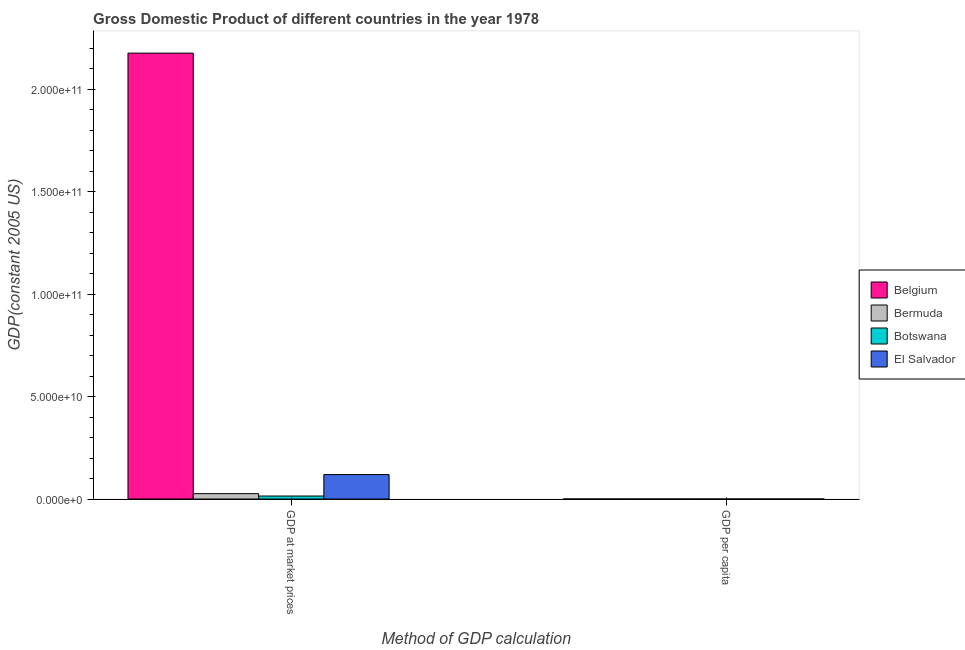Are the number of bars per tick equal to the number of legend labels?
Your answer should be compact. Yes. How many bars are there on the 2nd tick from the right?
Your answer should be compact. 4. What is the label of the 2nd group of bars from the left?
Provide a succinct answer. GDP per capita. What is the gdp at market prices in El Salvador?
Your answer should be compact. 1.19e+1. Across all countries, what is the maximum gdp per capita?
Offer a very short reply. 4.89e+04. Across all countries, what is the minimum gdp at market prices?
Ensure brevity in your answer.  1.46e+09. In which country was the gdp per capita maximum?
Offer a terse response. Bermuda. In which country was the gdp per capita minimum?
Offer a terse response. Botswana. What is the total gdp at market prices in the graph?
Ensure brevity in your answer.  2.34e+11. What is the difference between the gdp per capita in Bermuda and that in Botswana?
Offer a very short reply. 4.74e+04. What is the difference between the gdp per capita in Bermuda and the gdp at market prices in El Salvador?
Your response must be concise. -1.19e+1. What is the average gdp at market prices per country?
Provide a succinct answer. 5.84e+1. What is the difference between the gdp per capita and gdp at market prices in Belgium?
Offer a terse response. -2.18e+11. In how many countries, is the gdp at market prices greater than 140000000000 US$?
Give a very brief answer. 1. What is the ratio of the gdp per capita in Botswana to that in El Salvador?
Your answer should be very brief. 0.59. In how many countries, is the gdp per capita greater than the average gdp per capita taken over all countries?
Keep it short and to the point. 2. What does the 4th bar from the left in GDP per capita represents?
Provide a short and direct response. El Salvador. Are all the bars in the graph horizontal?
Keep it short and to the point. No. How many countries are there in the graph?
Give a very brief answer. 4. Are the values on the major ticks of Y-axis written in scientific E-notation?
Your answer should be compact. Yes. Does the graph contain any zero values?
Your answer should be very brief. No. Where does the legend appear in the graph?
Make the answer very short. Center right. How many legend labels are there?
Ensure brevity in your answer.  4. What is the title of the graph?
Provide a succinct answer. Gross Domestic Product of different countries in the year 1978. What is the label or title of the X-axis?
Make the answer very short. Method of GDP calculation. What is the label or title of the Y-axis?
Give a very brief answer. GDP(constant 2005 US). What is the GDP(constant 2005 US) of Belgium in GDP at market prices?
Give a very brief answer. 2.18e+11. What is the GDP(constant 2005 US) in Bermuda in GDP at market prices?
Your answer should be compact. 2.62e+09. What is the GDP(constant 2005 US) of Botswana in GDP at market prices?
Your answer should be compact. 1.46e+09. What is the GDP(constant 2005 US) in El Salvador in GDP at market prices?
Your response must be concise. 1.19e+1. What is the GDP(constant 2005 US) in Belgium in GDP per capita?
Make the answer very short. 2.21e+04. What is the GDP(constant 2005 US) of Bermuda in GDP per capita?
Provide a succinct answer. 4.89e+04. What is the GDP(constant 2005 US) of Botswana in GDP per capita?
Give a very brief answer. 1585.13. What is the GDP(constant 2005 US) in El Salvador in GDP per capita?
Give a very brief answer. 2701.73. Across all Method of GDP calculation, what is the maximum GDP(constant 2005 US) in Belgium?
Make the answer very short. 2.18e+11. Across all Method of GDP calculation, what is the maximum GDP(constant 2005 US) of Bermuda?
Your answer should be compact. 2.62e+09. Across all Method of GDP calculation, what is the maximum GDP(constant 2005 US) in Botswana?
Give a very brief answer. 1.46e+09. Across all Method of GDP calculation, what is the maximum GDP(constant 2005 US) of El Salvador?
Provide a short and direct response. 1.19e+1. Across all Method of GDP calculation, what is the minimum GDP(constant 2005 US) in Belgium?
Your answer should be very brief. 2.21e+04. Across all Method of GDP calculation, what is the minimum GDP(constant 2005 US) of Bermuda?
Give a very brief answer. 4.89e+04. Across all Method of GDP calculation, what is the minimum GDP(constant 2005 US) of Botswana?
Give a very brief answer. 1585.13. Across all Method of GDP calculation, what is the minimum GDP(constant 2005 US) of El Salvador?
Your response must be concise. 2701.73. What is the total GDP(constant 2005 US) in Belgium in the graph?
Ensure brevity in your answer.  2.18e+11. What is the total GDP(constant 2005 US) of Bermuda in the graph?
Give a very brief answer. 2.62e+09. What is the total GDP(constant 2005 US) of Botswana in the graph?
Offer a very short reply. 1.46e+09. What is the total GDP(constant 2005 US) of El Salvador in the graph?
Offer a terse response. 1.19e+1. What is the difference between the GDP(constant 2005 US) in Belgium in GDP at market prices and that in GDP per capita?
Provide a succinct answer. 2.18e+11. What is the difference between the GDP(constant 2005 US) of Bermuda in GDP at market prices and that in GDP per capita?
Keep it short and to the point. 2.62e+09. What is the difference between the GDP(constant 2005 US) of Botswana in GDP at market prices and that in GDP per capita?
Make the answer very short. 1.46e+09. What is the difference between the GDP(constant 2005 US) in El Salvador in GDP at market prices and that in GDP per capita?
Your answer should be compact. 1.19e+1. What is the difference between the GDP(constant 2005 US) of Belgium in GDP at market prices and the GDP(constant 2005 US) of Bermuda in GDP per capita?
Your response must be concise. 2.18e+11. What is the difference between the GDP(constant 2005 US) of Belgium in GDP at market prices and the GDP(constant 2005 US) of Botswana in GDP per capita?
Provide a short and direct response. 2.18e+11. What is the difference between the GDP(constant 2005 US) of Belgium in GDP at market prices and the GDP(constant 2005 US) of El Salvador in GDP per capita?
Your response must be concise. 2.18e+11. What is the difference between the GDP(constant 2005 US) in Bermuda in GDP at market prices and the GDP(constant 2005 US) in Botswana in GDP per capita?
Ensure brevity in your answer.  2.62e+09. What is the difference between the GDP(constant 2005 US) of Bermuda in GDP at market prices and the GDP(constant 2005 US) of El Salvador in GDP per capita?
Provide a succinct answer. 2.62e+09. What is the difference between the GDP(constant 2005 US) of Botswana in GDP at market prices and the GDP(constant 2005 US) of El Salvador in GDP per capita?
Offer a terse response. 1.46e+09. What is the average GDP(constant 2005 US) in Belgium per Method of GDP calculation?
Offer a very short reply. 1.09e+11. What is the average GDP(constant 2005 US) of Bermuda per Method of GDP calculation?
Make the answer very short. 1.31e+09. What is the average GDP(constant 2005 US) of Botswana per Method of GDP calculation?
Your response must be concise. 7.32e+08. What is the average GDP(constant 2005 US) in El Salvador per Method of GDP calculation?
Your answer should be compact. 5.96e+09. What is the difference between the GDP(constant 2005 US) of Belgium and GDP(constant 2005 US) of Bermuda in GDP at market prices?
Your answer should be very brief. 2.15e+11. What is the difference between the GDP(constant 2005 US) in Belgium and GDP(constant 2005 US) in Botswana in GDP at market prices?
Make the answer very short. 2.16e+11. What is the difference between the GDP(constant 2005 US) in Belgium and GDP(constant 2005 US) in El Salvador in GDP at market prices?
Offer a terse response. 2.06e+11. What is the difference between the GDP(constant 2005 US) of Bermuda and GDP(constant 2005 US) of Botswana in GDP at market prices?
Provide a succinct answer. 1.16e+09. What is the difference between the GDP(constant 2005 US) in Bermuda and GDP(constant 2005 US) in El Salvador in GDP at market prices?
Your answer should be compact. -9.31e+09. What is the difference between the GDP(constant 2005 US) of Botswana and GDP(constant 2005 US) of El Salvador in GDP at market prices?
Provide a succinct answer. -1.05e+1. What is the difference between the GDP(constant 2005 US) of Belgium and GDP(constant 2005 US) of Bermuda in GDP per capita?
Keep it short and to the point. -2.68e+04. What is the difference between the GDP(constant 2005 US) in Belgium and GDP(constant 2005 US) in Botswana in GDP per capita?
Provide a short and direct response. 2.05e+04. What is the difference between the GDP(constant 2005 US) of Belgium and GDP(constant 2005 US) of El Salvador in GDP per capita?
Provide a short and direct response. 1.94e+04. What is the difference between the GDP(constant 2005 US) in Bermuda and GDP(constant 2005 US) in Botswana in GDP per capita?
Keep it short and to the point. 4.74e+04. What is the difference between the GDP(constant 2005 US) in Bermuda and GDP(constant 2005 US) in El Salvador in GDP per capita?
Give a very brief answer. 4.62e+04. What is the difference between the GDP(constant 2005 US) in Botswana and GDP(constant 2005 US) in El Salvador in GDP per capita?
Ensure brevity in your answer.  -1116.6. What is the ratio of the GDP(constant 2005 US) of Belgium in GDP at market prices to that in GDP per capita?
Your response must be concise. 9.84e+06. What is the ratio of the GDP(constant 2005 US) in Bermuda in GDP at market prices to that in GDP per capita?
Your response must be concise. 5.36e+04. What is the ratio of the GDP(constant 2005 US) of Botswana in GDP at market prices to that in GDP per capita?
Make the answer very short. 9.23e+05. What is the ratio of the GDP(constant 2005 US) in El Salvador in GDP at market prices to that in GDP per capita?
Offer a terse response. 4.42e+06. What is the difference between the highest and the second highest GDP(constant 2005 US) in Belgium?
Ensure brevity in your answer.  2.18e+11. What is the difference between the highest and the second highest GDP(constant 2005 US) in Bermuda?
Give a very brief answer. 2.62e+09. What is the difference between the highest and the second highest GDP(constant 2005 US) of Botswana?
Your answer should be compact. 1.46e+09. What is the difference between the highest and the second highest GDP(constant 2005 US) in El Salvador?
Ensure brevity in your answer.  1.19e+1. What is the difference between the highest and the lowest GDP(constant 2005 US) of Belgium?
Ensure brevity in your answer.  2.18e+11. What is the difference between the highest and the lowest GDP(constant 2005 US) in Bermuda?
Provide a succinct answer. 2.62e+09. What is the difference between the highest and the lowest GDP(constant 2005 US) of Botswana?
Ensure brevity in your answer.  1.46e+09. What is the difference between the highest and the lowest GDP(constant 2005 US) of El Salvador?
Your answer should be compact. 1.19e+1. 